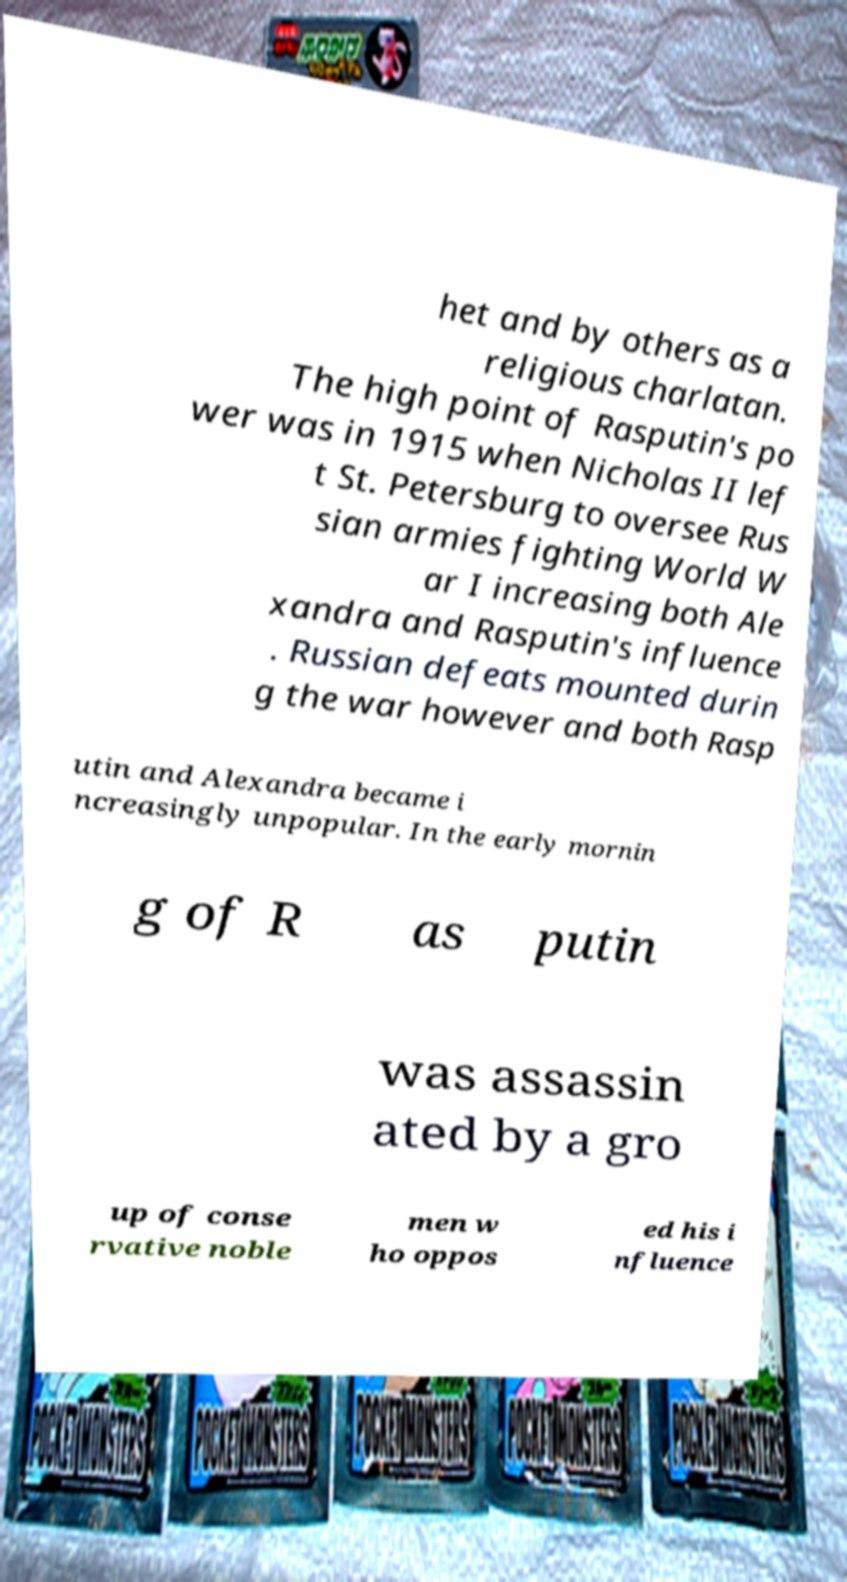Could you extract and type out the text from this image? het and by others as a religious charlatan. The high point of Rasputin's po wer was in 1915 when Nicholas II lef t St. Petersburg to oversee Rus sian armies fighting World W ar I increasing both Ale xandra and Rasputin's influence . Russian defeats mounted durin g the war however and both Rasp utin and Alexandra became i ncreasingly unpopular. In the early mornin g of R as putin was assassin ated by a gro up of conse rvative noble men w ho oppos ed his i nfluence 